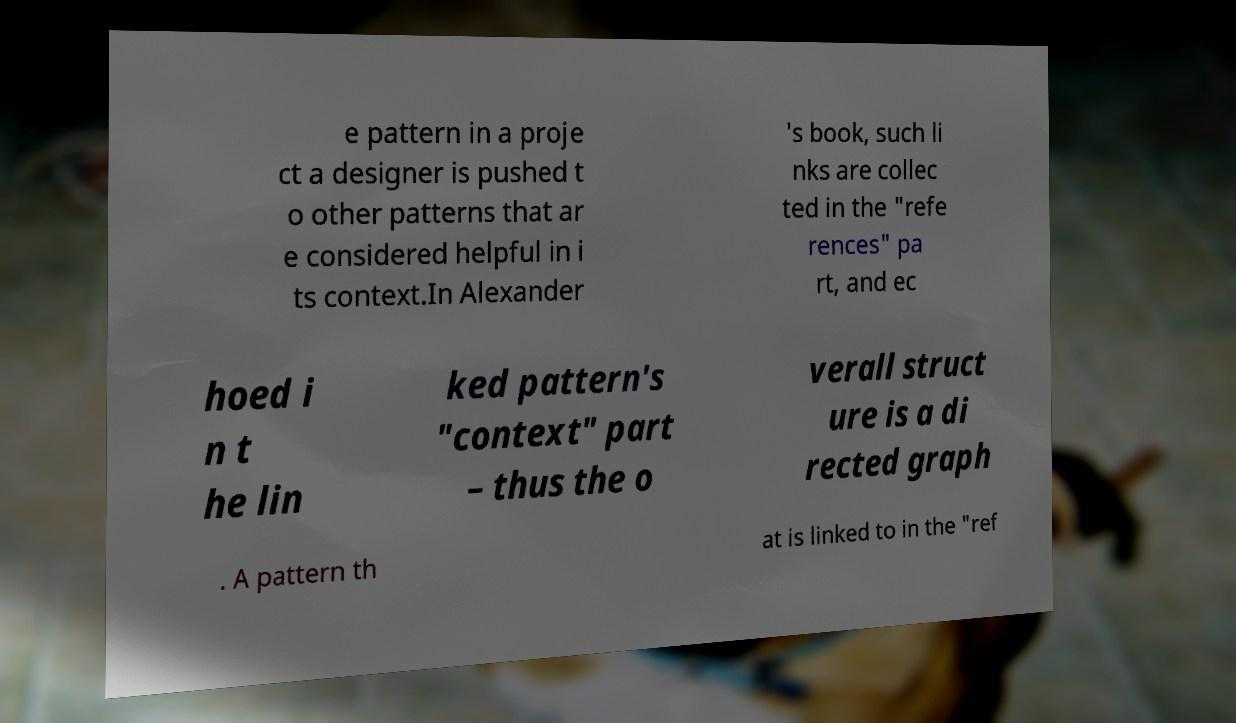What messages or text are displayed in this image? I need them in a readable, typed format. e pattern in a proje ct a designer is pushed t o other patterns that ar e considered helpful in i ts context.In Alexander 's book, such li nks are collec ted in the "refe rences" pa rt, and ec hoed i n t he lin ked pattern's "context" part – thus the o verall struct ure is a di rected graph . A pattern th at is linked to in the "ref 